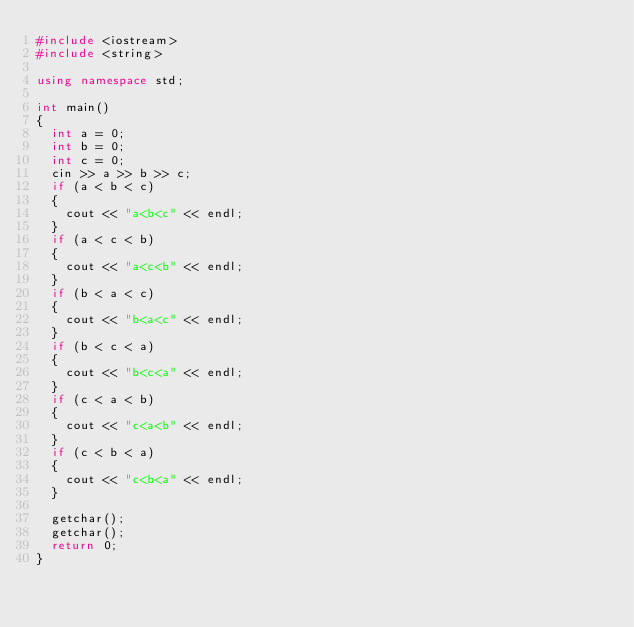Convert code to text. <code><loc_0><loc_0><loc_500><loc_500><_C++_>#include <iostream>
#include <string>

using namespace std;

int main()
{
	int a = 0;
	int b = 0;
	int c = 0;
	cin >> a >> b >> c;
	if (a < b < c)
	{
		cout << "a<b<c" << endl;
	}
	if (a < c < b)
	{
		cout << "a<c<b" << endl;
	}
	if (b < a < c)
	{
		cout << "b<a<c" << endl;
	}
	if (b < c < a)
	{
		cout << "b<c<a" << endl;
	}
	if (c < a < b)
	{
		cout << "c<a<b" << endl;
	}
	if (c < b < a)
	{
		cout << "c<b<a" << endl;
	}

	getchar();
	getchar();
	return 0;
}</code> 